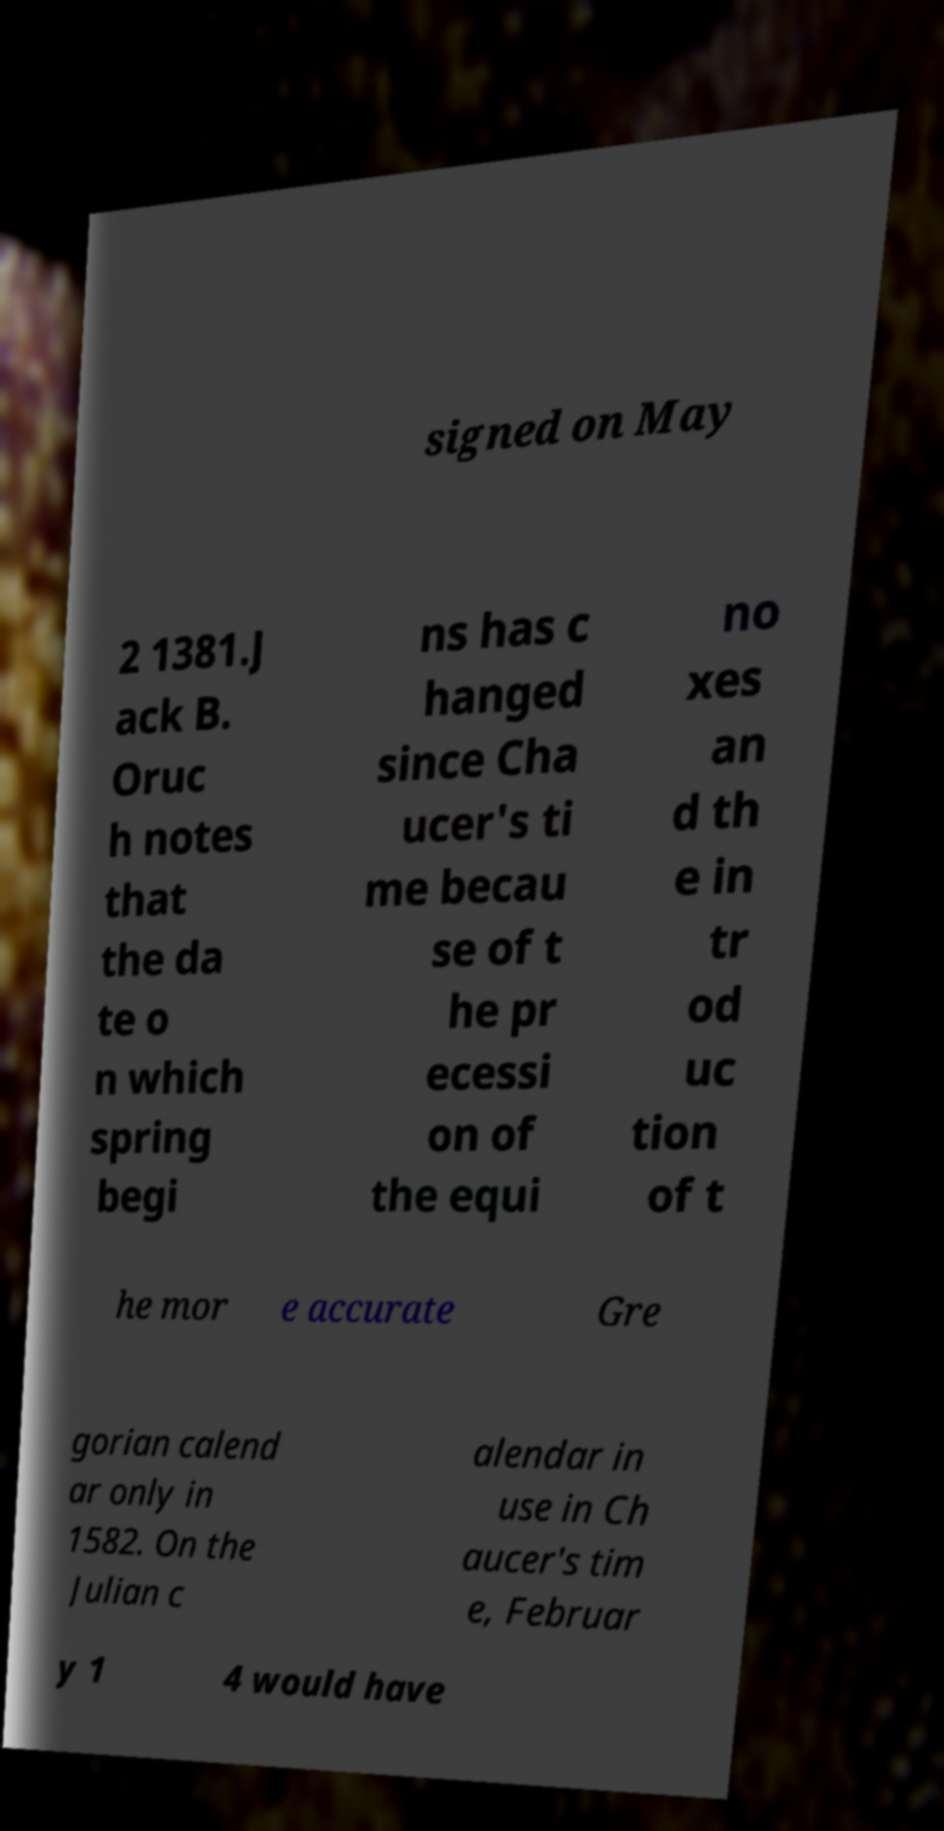For documentation purposes, I need the text within this image transcribed. Could you provide that? signed on May 2 1381.J ack B. Oruc h notes that the da te o n which spring begi ns has c hanged since Cha ucer's ti me becau se of t he pr ecessi on of the equi no xes an d th e in tr od uc tion of t he mor e accurate Gre gorian calend ar only in 1582. On the Julian c alendar in use in Ch aucer's tim e, Februar y 1 4 would have 